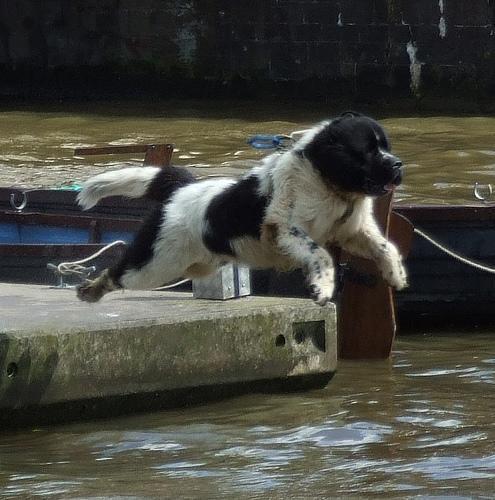How many boats are there?
Give a very brief answer. 2. 